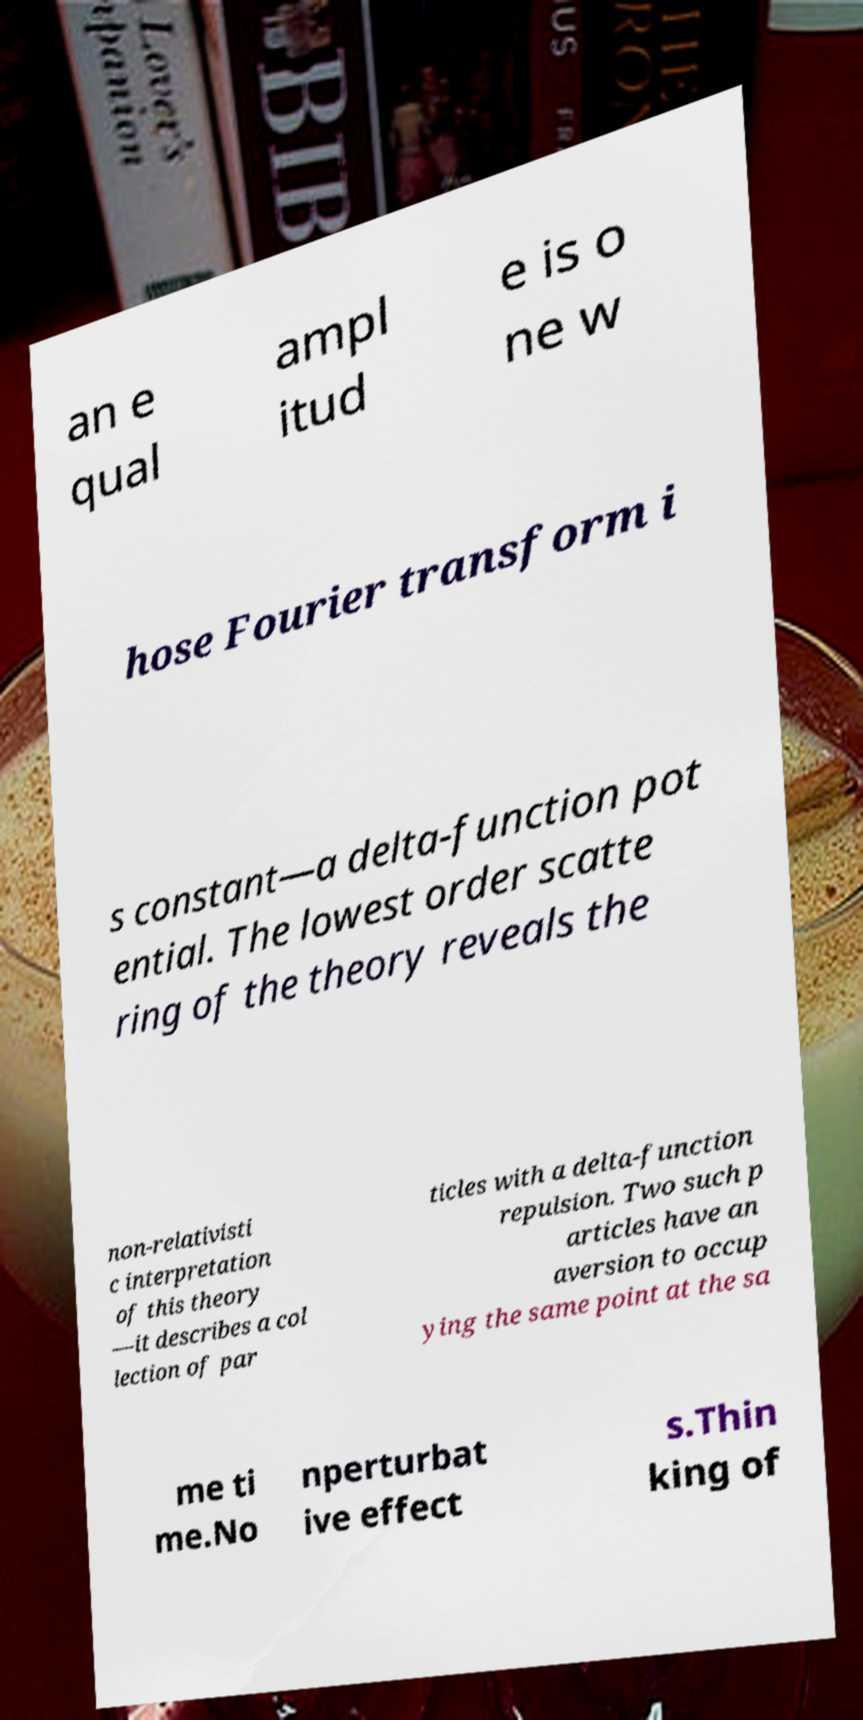What messages or text are displayed in this image? I need them in a readable, typed format. an e qual ampl itud e is o ne w hose Fourier transform i s constant—a delta-function pot ential. The lowest order scatte ring of the theory reveals the non-relativisti c interpretation of this theory —it describes a col lection of par ticles with a delta-function repulsion. Two such p articles have an aversion to occup ying the same point at the sa me ti me.No nperturbat ive effect s.Thin king of 